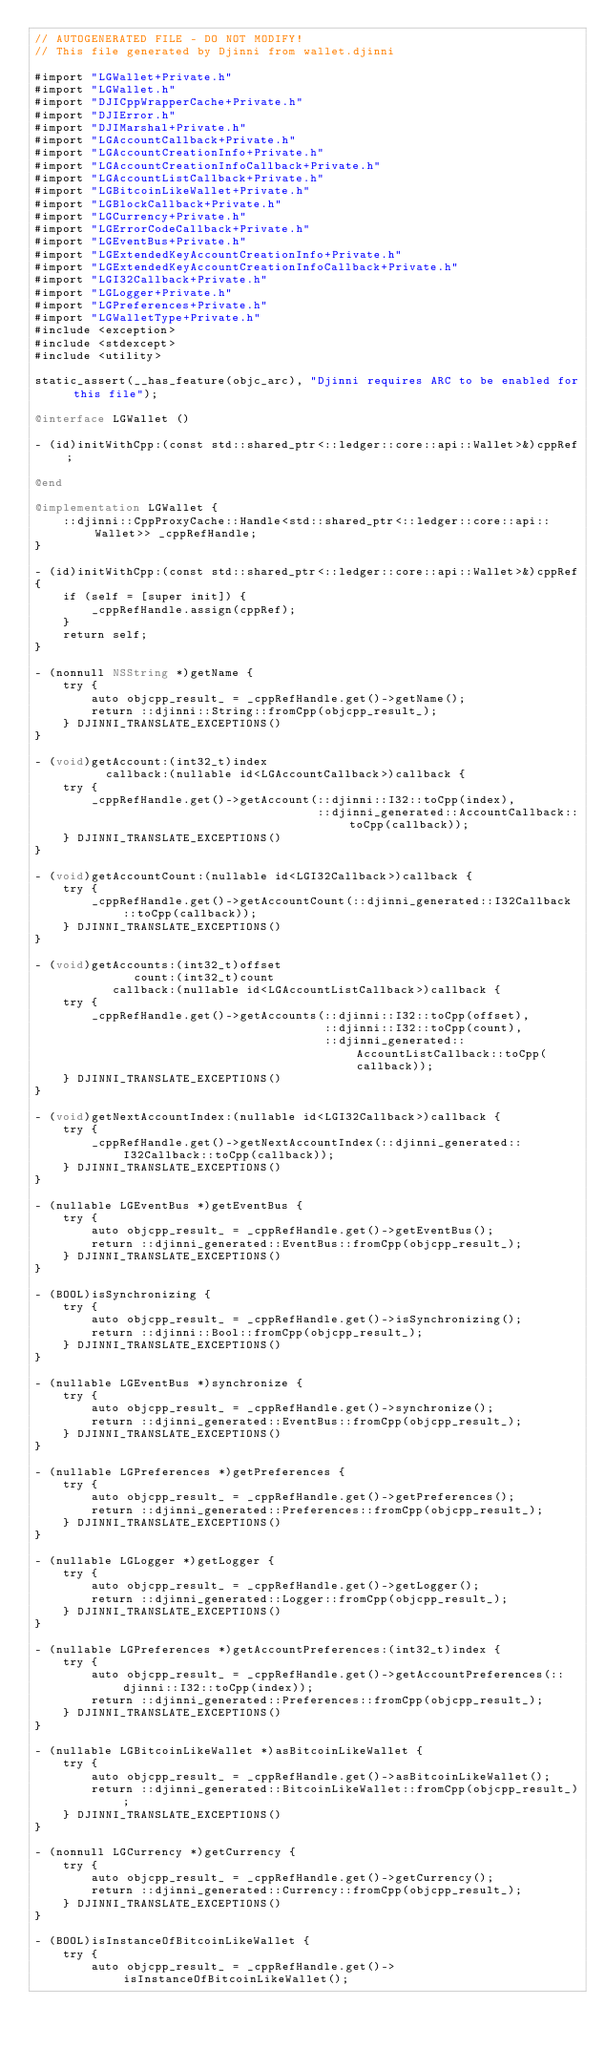Convert code to text. <code><loc_0><loc_0><loc_500><loc_500><_ObjectiveC_>// AUTOGENERATED FILE - DO NOT MODIFY!
// This file generated by Djinni from wallet.djinni

#import "LGWallet+Private.h"
#import "LGWallet.h"
#import "DJICppWrapperCache+Private.h"
#import "DJIError.h"
#import "DJIMarshal+Private.h"
#import "LGAccountCallback+Private.h"
#import "LGAccountCreationInfo+Private.h"
#import "LGAccountCreationInfoCallback+Private.h"
#import "LGAccountListCallback+Private.h"
#import "LGBitcoinLikeWallet+Private.h"
#import "LGBlockCallback+Private.h"
#import "LGCurrency+Private.h"
#import "LGErrorCodeCallback+Private.h"
#import "LGEventBus+Private.h"
#import "LGExtendedKeyAccountCreationInfo+Private.h"
#import "LGExtendedKeyAccountCreationInfoCallback+Private.h"
#import "LGI32Callback+Private.h"
#import "LGLogger+Private.h"
#import "LGPreferences+Private.h"
#import "LGWalletType+Private.h"
#include <exception>
#include <stdexcept>
#include <utility>

static_assert(__has_feature(objc_arc), "Djinni requires ARC to be enabled for this file");

@interface LGWallet ()

- (id)initWithCpp:(const std::shared_ptr<::ledger::core::api::Wallet>&)cppRef;

@end

@implementation LGWallet {
    ::djinni::CppProxyCache::Handle<std::shared_ptr<::ledger::core::api::Wallet>> _cppRefHandle;
}

- (id)initWithCpp:(const std::shared_ptr<::ledger::core::api::Wallet>&)cppRef
{
    if (self = [super init]) {
        _cppRefHandle.assign(cppRef);
    }
    return self;
}

- (nonnull NSString *)getName {
    try {
        auto objcpp_result_ = _cppRefHandle.get()->getName();
        return ::djinni::String::fromCpp(objcpp_result_);
    } DJINNI_TRANSLATE_EXCEPTIONS()
}

- (void)getAccount:(int32_t)index
          callback:(nullable id<LGAccountCallback>)callback {
    try {
        _cppRefHandle.get()->getAccount(::djinni::I32::toCpp(index),
                                        ::djinni_generated::AccountCallback::toCpp(callback));
    } DJINNI_TRANSLATE_EXCEPTIONS()
}

- (void)getAccountCount:(nullable id<LGI32Callback>)callback {
    try {
        _cppRefHandle.get()->getAccountCount(::djinni_generated::I32Callback::toCpp(callback));
    } DJINNI_TRANSLATE_EXCEPTIONS()
}

- (void)getAccounts:(int32_t)offset
              count:(int32_t)count
           callback:(nullable id<LGAccountListCallback>)callback {
    try {
        _cppRefHandle.get()->getAccounts(::djinni::I32::toCpp(offset),
                                         ::djinni::I32::toCpp(count),
                                         ::djinni_generated::AccountListCallback::toCpp(callback));
    } DJINNI_TRANSLATE_EXCEPTIONS()
}

- (void)getNextAccountIndex:(nullable id<LGI32Callback>)callback {
    try {
        _cppRefHandle.get()->getNextAccountIndex(::djinni_generated::I32Callback::toCpp(callback));
    } DJINNI_TRANSLATE_EXCEPTIONS()
}

- (nullable LGEventBus *)getEventBus {
    try {
        auto objcpp_result_ = _cppRefHandle.get()->getEventBus();
        return ::djinni_generated::EventBus::fromCpp(objcpp_result_);
    } DJINNI_TRANSLATE_EXCEPTIONS()
}

- (BOOL)isSynchronizing {
    try {
        auto objcpp_result_ = _cppRefHandle.get()->isSynchronizing();
        return ::djinni::Bool::fromCpp(objcpp_result_);
    } DJINNI_TRANSLATE_EXCEPTIONS()
}

- (nullable LGEventBus *)synchronize {
    try {
        auto objcpp_result_ = _cppRefHandle.get()->synchronize();
        return ::djinni_generated::EventBus::fromCpp(objcpp_result_);
    } DJINNI_TRANSLATE_EXCEPTIONS()
}

- (nullable LGPreferences *)getPreferences {
    try {
        auto objcpp_result_ = _cppRefHandle.get()->getPreferences();
        return ::djinni_generated::Preferences::fromCpp(objcpp_result_);
    } DJINNI_TRANSLATE_EXCEPTIONS()
}

- (nullable LGLogger *)getLogger {
    try {
        auto objcpp_result_ = _cppRefHandle.get()->getLogger();
        return ::djinni_generated::Logger::fromCpp(objcpp_result_);
    } DJINNI_TRANSLATE_EXCEPTIONS()
}

- (nullable LGPreferences *)getAccountPreferences:(int32_t)index {
    try {
        auto objcpp_result_ = _cppRefHandle.get()->getAccountPreferences(::djinni::I32::toCpp(index));
        return ::djinni_generated::Preferences::fromCpp(objcpp_result_);
    } DJINNI_TRANSLATE_EXCEPTIONS()
}

- (nullable LGBitcoinLikeWallet *)asBitcoinLikeWallet {
    try {
        auto objcpp_result_ = _cppRefHandle.get()->asBitcoinLikeWallet();
        return ::djinni_generated::BitcoinLikeWallet::fromCpp(objcpp_result_);
    } DJINNI_TRANSLATE_EXCEPTIONS()
}

- (nonnull LGCurrency *)getCurrency {
    try {
        auto objcpp_result_ = _cppRefHandle.get()->getCurrency();
        return ::djinni_generated::Currency::fromCpp(objcpp_result_);
    } DJINNI_TRANSLATE_EXCEPTIONS()
}

- (BOOL)isInstanceOfBitcoinLikeWallet {
    try {
        auto objcpp_result_ = _cppRefHandle.get()->isInstanceOfBitcoinLikeWallet();</code> 